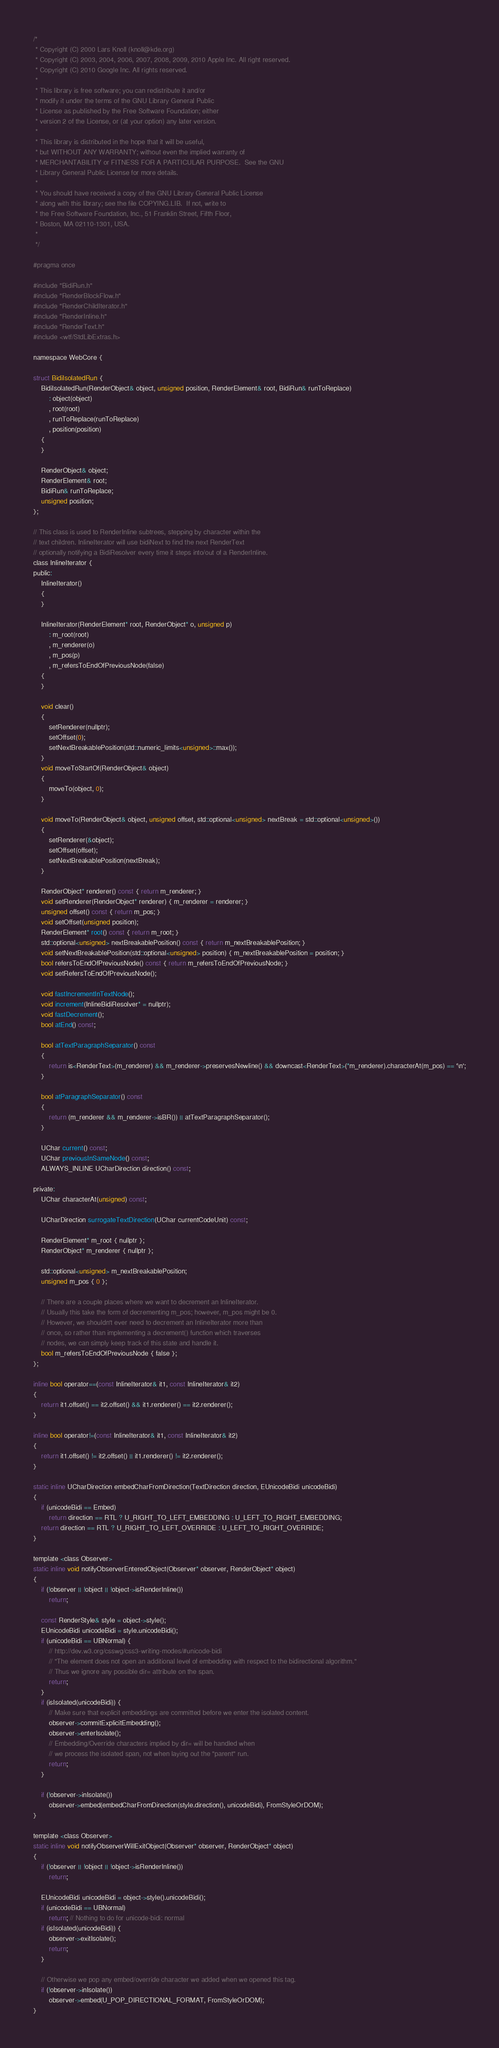<code> <loc_0><loc_0><loc_500><loc_500><_C_>/*
 * Copyright (C) 2000 Lars Knoll (knoll@kde.org)
 * Copyright (C) 2003, 2004, 2006, 2007, 2008, 2009, 2010 Apple Inc. All right reserved.
 * Copyright (C) 2010 Google Inc. All rights reserved.
 *
 * This library is free software; you can redistribute it and/or
 * modify it under the terms of the GNU Library General Public
 * License as published by the Free Software Foundation; either
 * version 2 of the License, or (at your option) any later version.
 *
 * This library is distributed in the hope that it will be useful,
 * but WITHOUT ANY WARRANTY; without even the implied warranty of
 * MERCHANTABILITY or FITNESS FOR A PARTICULAR PURPOSE.  See the GNU
 * Library General Public License for more details.
 *
 * You should have received a copy of the GNU Library General Public License
 * along with this library; see the file COPYING.LIB.  If not, write to
 * the Free Software Foundation, Inc., 51 Franklin Street, Fifth Floor,
 * Boston, MA 02110-1301, USA.
 *
 */

#pragma once

#include "BidiRun.h"
#include "RenderBlockFlow.h"
#include "RenderChildIterator.h"
#include "RenderInline.h"
#include "RenderText.h"
#include <wtf/StdLibExtras.h>

namespace WebCore {

struct BidiIsolatedRun {
    BidiIsolatedRun(RenderObject& object, unsigned position, RenderElement& root, BidiRun& runToReplace)
        : object(object)
        , root(root)
        , runToReplace(runToReplace)
        , position(position)
    {
    }

    RenderObject& object;
    RenderElement& root;
    BidiRun& runToReplace;
    unsigned position;
};

// This class is used to RenderInline subtrees, stepping by character within the
// text children. InlineIterator will use bidiNext to find the next RenderText
// optionally notifying a BidiResolver every time it steps into/out of a RenderInline.
class InlineIterator {
public:
    InlineIterator()
    {
    }

    InlineIterator(RenderElement* root, RenderObject* o, unsigned p)
        : m_root(root)
        , m_renderer(o)
        , m_pos(p)
        , m_refersToEndOfPreviousNode(false)
    {
    }

    void clear()
    {
        setRenderer(nullptr);
        setOffset(0);
        setNextBreakablePosition(std::numeric_limits<unsigned>::max());
    }
    void moveToStartOf(RenderObject& object)
    {
        moveTo(object, 0);
    }

    void moveTo(RenderObject& object, unsigned offset, std::optional<unsigned> nextBreak = std::optional<unsigned>())
    {
        setRenderer(&object);
        setOffset(offset);
        setNextBreakablePosition(nextBreak);
    }

    RenderObject* renderer() const { return m_renderer; }
    void setRenderer(RenderObject* renderer) { m_renderer = renderer; }
    unsigned offset() const { return m_pos; }
    void setOffset(unsigned position);
    RenderElement* root() const { return m_root; }
    std::optional<unsigned> nextBreakablePosition() const { return m_nextBreakablePosition; }
    void setNextBreakablePosition(std::optional<unsigned> position) { m_nextBreakablePosition = position; }
    bool refersToEndOfPreviousNode() const { return m_refersToEndOfPreviousNode; }
    void setRefersToEndOfPreviousNode();

    void fastIncrementInTextNode();
    void increment(InlineBidiResolver* = nullptr);
    void fastDecrement();
    bool atEnd() const;

    bool atTextParagraphSeparator() const
    {
        return is<RenderText>(m_renderer) && m_renderer->preservesNewline() && downcast<RenderText>(*m_renderer).characterAt(m_pos) == '\n';
    }
    
    bool atParagraphSeparator() const
    {
        return (m_renderer && m_renderer->isBR()) || atTextParagraphSeparator();
    }

    UChar current() const;
    UChar previousInSameNode() const;
    ALWAYS_INLINE UCharDirection direction() const;

private:
    UChar characterAt(unsigned) const;

    UCharDirection surrogateTextDirection(UChar currentCodeUnit) const;

    RenderElement* m_root { nullptr };
    RenderObject* m_renderer { nullptr };

    std::optional<unsigned> m_nextBreakablePosition;
    unsigned m_pos { 0 };

    // There are a couple places where we want to decrement an InlineIterator.
    // Usually this take the form of decrementing m_pos; however, m_pos might be 0.
    // However, we shouldn't ever need to decrement an InlineIterator more than
    // once, so rather than implementing a decrement() function which traverses
    // nodes, we can simply keep track of this state and handle it.
    bool m_refersToEndOfPreviousNode { false };
};

inline bool operator==(const InlineIterator& it1, const InlineIterator& it2)
{
    return it1.offset() == it2.offset() && it1.renderer() == it2.renderer();
}

inline bool operator!=(const InlineIterator& it1, const InlineIterator& it2)
{
    return it1.offset() != it2.offset() || it1.renderer() != it2.renderer();
}

static inline UCharDirection embedCharFromDirection(TextDirection direction, EUnicodeBidi unicodeBidi)
{
    if (unicodeBidi == Embed)
        return direction == RTL ? U_RIGHT_TO_LEFT_EMBEDDING : U_LEFT_TO_RIGHT_EMBEDDING;
    return direction == RTL ? U_RIGHT_TO_LEFT_OVERRIDE : U_LEFT_TO_RIGHT_OVERRIDE;
}

template <class Observer>
static inline void notifyObserverEnteredObject(Observer* observer, RenderObject* object)
{
    if (!observer || !object || !object->isRenderInline())
        return;

    const RenderStyle& style = object->style();
    EUnicodeBidi unicodeBidi = style.unicodeBidi();
    if (unicodeBidi == UBNormal) {
        // http://dev.w3.org/csswg/css3-writing-modes/#unicode-bidi
        // "The element does not open an additional level of embedding with respect to the bidirectional algorithm."
        // Thus we ignore any possible dir= attribute on the span.
        return;
    }
    if (isIsolated(unicodeBidi)) {
        // Make sure that explicit embeddings are committed before we enter the isolated content.
        observer->commitExplicitEmbedding();
        observer->enterIsolate();
        // Embedding/Override characters implied by dir= will be handled when
        // we process the isolated span, not when laying out the "parent" run.
        return;
    }

    if (!observer->inIsolate())
        observer->embed(embedCharFromDirection(style.direction(), unicodeBidi), FromStyleOrDOM);
}

template <class Observer>
static inline void notifyObserverWillExitObject(Observer* observer, RenderObject* object)
{
    if (!observer || !object || !object->isRenderInline())
        return;

    EUnicodeBidi unicodeBidi = object->style().unicodeBidi();
    if (unicodeBidi == UBNormal)
        return; // Nothing to do for unicode-bidi: normal
    if (isIsolated(unicodeBidi)) {
        observer->exitIsolate();
        return;
    }

    // Otherwise we pop any embed/override character we added when we opened this tag.
    if (!observer->inIsolate())
        observer->embed(U_POP_DIRECTIONAL_FORMAT, FromStyleOrDOM);
}
</code> 